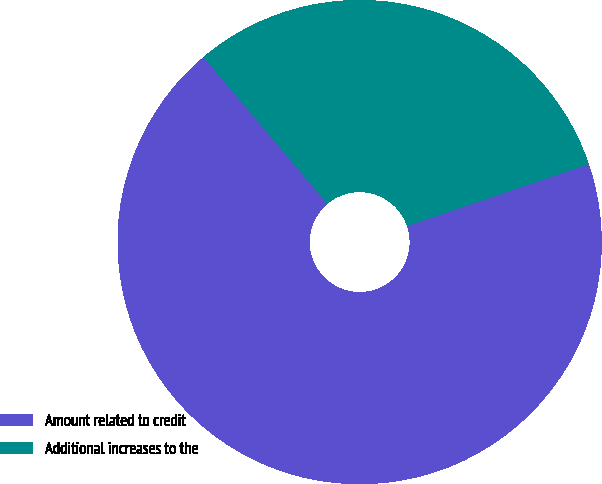<chart> <loc_0><loc_0><loc_500><loc_500><pie_chart><fcel>Amount related to credit<fcel>Additional increases to the<nl><fcel>69.06%<fcel>30.94%<nl></chart> 